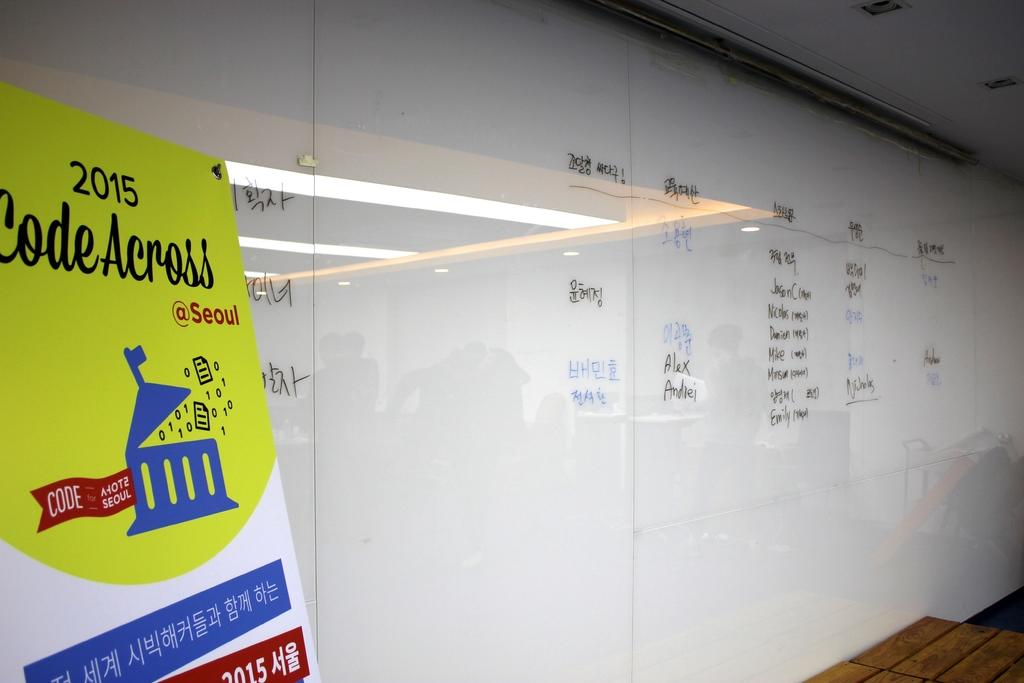<image>
Describe the image concisely. A white board is behind a sign that says 2015  Code Across. 